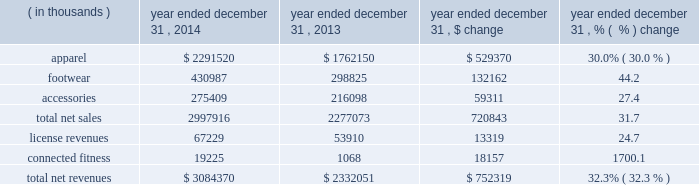Other expense , net increased $ 0.8 million to $ 7.2 million in 2015 from $ 6.4 million in 2014 .
This increase was due to higher net losses on the combined foreign currency exchange rate changes on transactions denominated in foreign currencies and our foreign currency derivative financial instruments in 2015 .
Provision for income taxes increased $ 19.9 million to $ 154.1 million in 2015 from $ 134.2 million in 2014 .
Our effective tax rate was 39.9% ( 39.9 % ) in 2015 compared to 39.2% ( 39.2 % ) in 2014 .
Our effective tax rate for 2015 was higher than the effective tax rate for 2014 primarily due to increased non-deductible costs incurred in connection with our connected fitness acquisitions in 2015 .
Year ended december 31 , 2014 compared to year ended december 31 , 2013 net revenues increased $ 752.3 million , or 32.3% ( 32.3 % ) , to $ 3084.4 million in 2014 from $ 2332.1 million in 2013 .
Net revenues by product category are summarized below: .
The increase in net sales were driven primarily by : 2022 apparel unit sales growth and new offerings in multiple lines led by training , hunt and golf ; and 2022 footwear unit sales growth , led by running and basketball .
License revenues increased $ 13.3 million , or 24.7% ( 24.7 % ) , to $ 67.2 million in 2014 from $ 53.9 million in 2013 .
This increase in license revenues was primarily a result of increased distribution and continued unit volume growth by our licensees .
Connected fitness revenue increased $ 18.1 million to $ 19.2 million in 2014 from $ 1.1 million in 2013 primarily due to a full year of revenue from our connected fitness business in 2014 compared to one month in gross profit increased $ 375.5 million to $ 1512.2 million in 2014 from $ 1136.7 million in 2013 .
Gross profit as a percentage of net revenues , or gross margin , increased 30 basis points to 49.0% ( 49.0 % ) in 2014 compared to 48.7% ( 48.7 % ) in 2013 .
The increase in gross margin percentage was primarily driven by the following : 2022 approximate 20 basis point increase driven primarily by decreased sales mix of excess inventory through our factory house outlet stores ; and 2022 approximate 20 basis point increase as a result of higher duty costs recorded during the prior year on certain products imported in previous years .
The above increases were partially offset by : 2022 approximate 10 basis point decrease by unfavorable foreign currency exchange rate fluctuations. .
What was the percent of growth of the sales revenues of apparel from 2013 to 2014? 
Rationale: the sales revenues of apparel grew by 30% from 2013 to 2014
Computations: ((2291520 - 1762150) / 1762150)
Answer: 0.30041. 